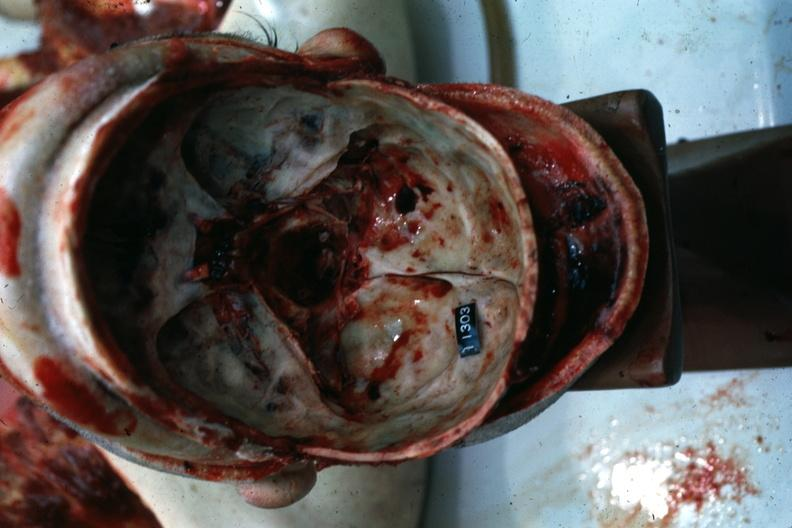what is present?
Answer the question using a single word or phrase. Bone 